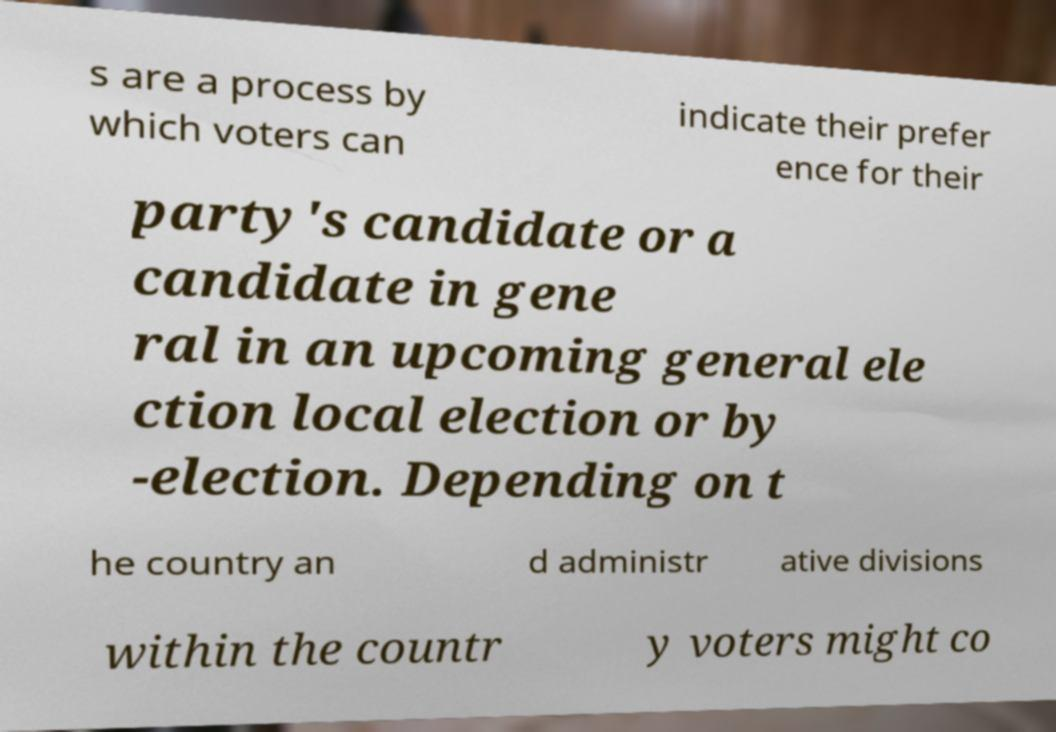Could you assist in decoding the text presented in this image and type it out clearly? s are a process by which voters can indicate their prefer ence for their party's candidate or a candidate in gene ral in an upcoming general ele ction local election or by -election. Depending on t he country an d administr ative divisions within the countr y voters might co 